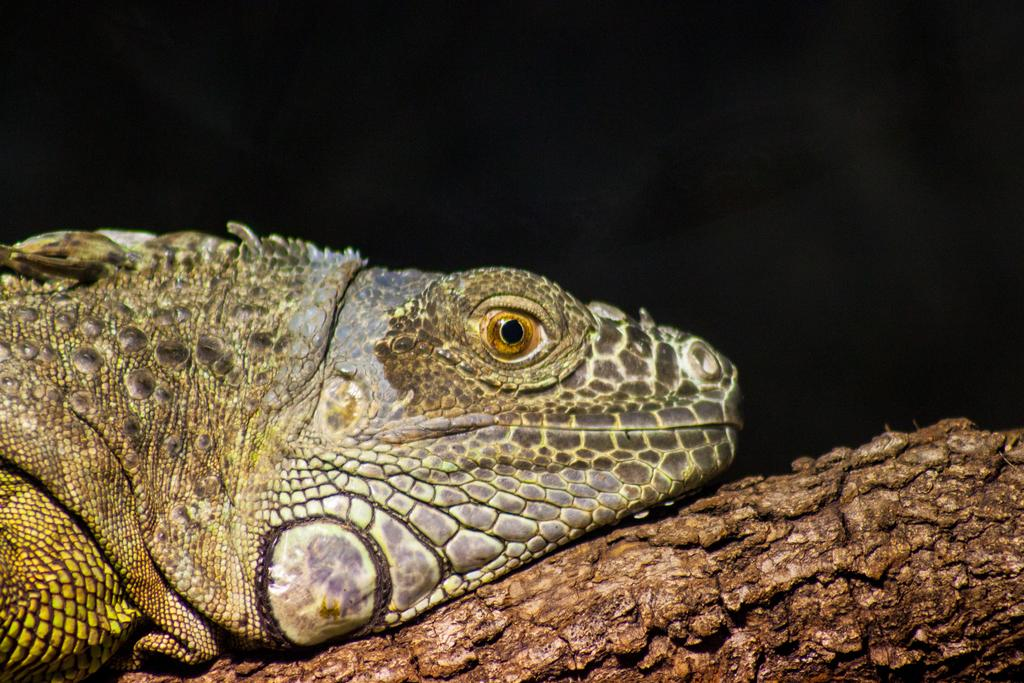What type of animal is in the image? There is a reptile in the image. What is the reptile resting on? The reptile is on a wooden object. How would you describe the lighting in the image? The background of the image is dark. What type of camera is visible in the image? There is no camera present in the image. What type of chair is the reptile sitting on? The reptile is not sitting on a chair; it is on a wooden object. 